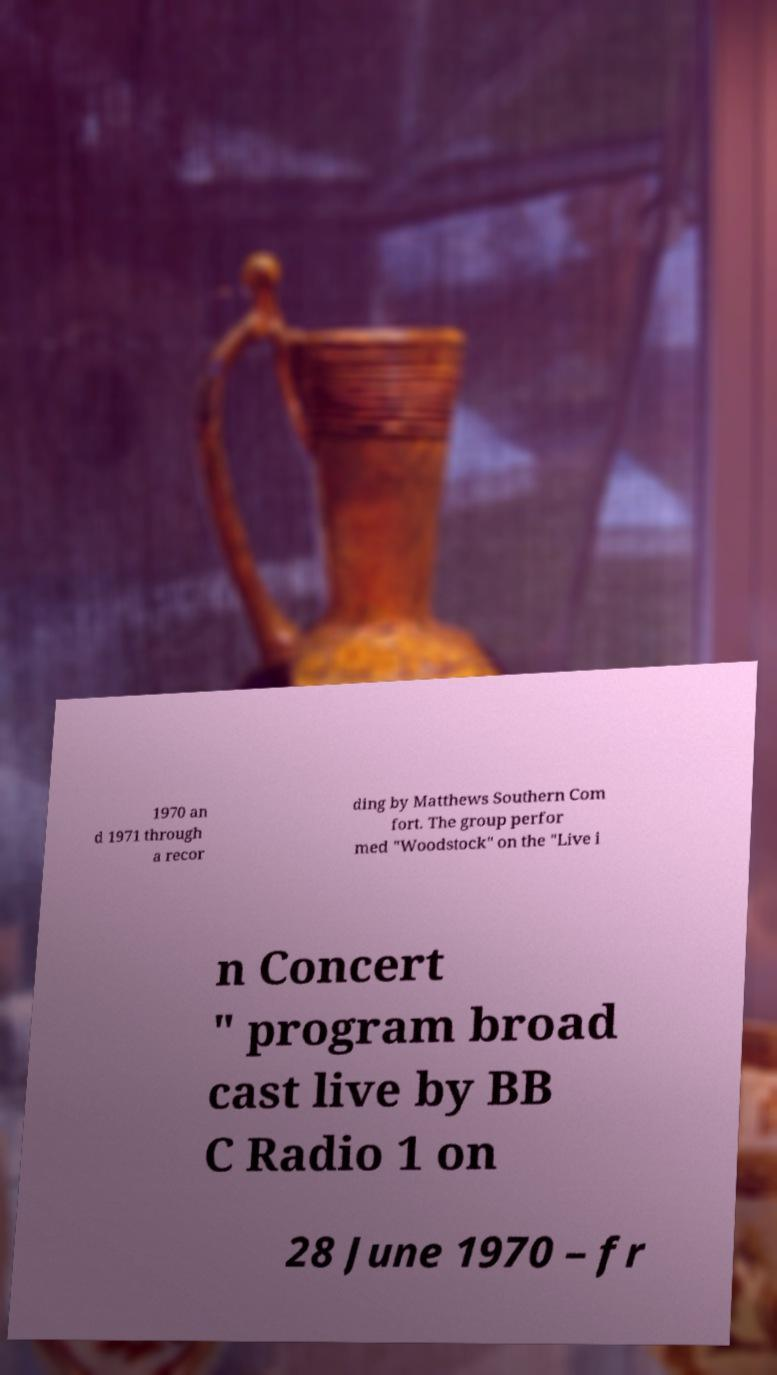Can you read and provide the text displayed in the image?This photo seems to have some interesting text. Can you extract and type it out for me? 1970 an d 1971 through a recor ding by Matthews Southern Com fort. The group perfor med "Woodstock" on the "Live i n Concert " program broad cast live by BB C Radio 1 on 28 June 1970 – fr 